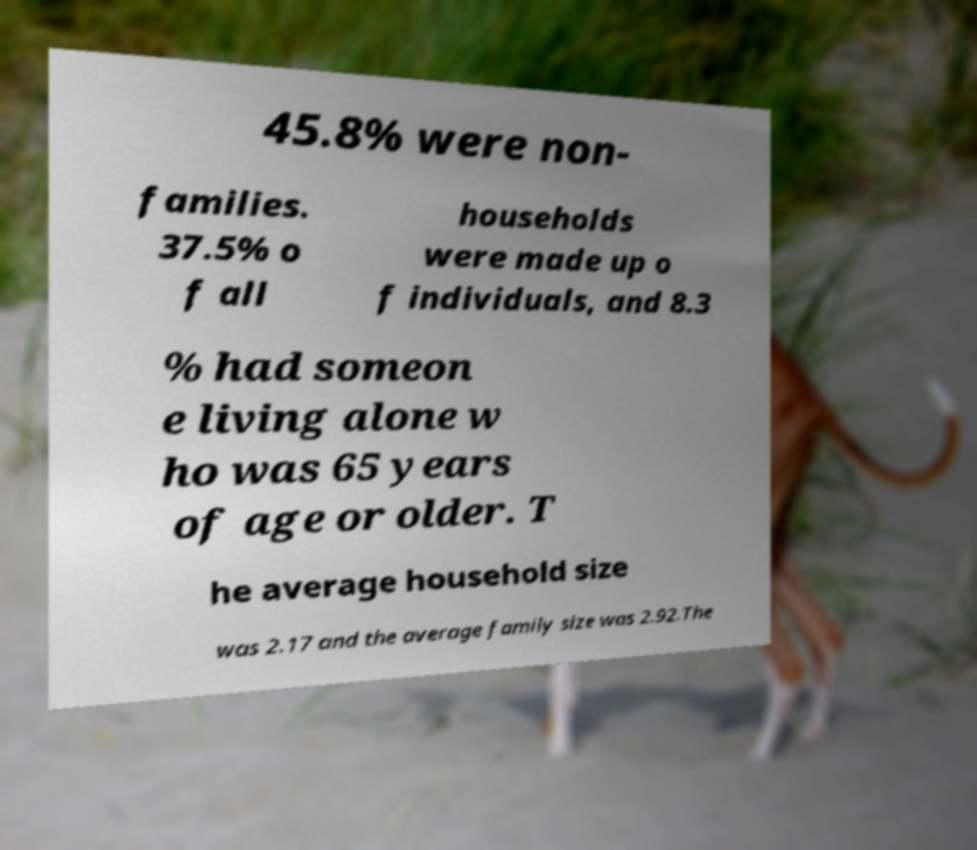Can you read and provide the text displayed in the image?This photo seems to have some interesting text. Can you extract and type it out for me? 45.8% were non- families. 37.5% o f all households were made up o f individuals, and 8.3 % had someon e living alone w ho was 65 years of age or older. T he average household size was 2.17 and the average family size was 2.92.The 